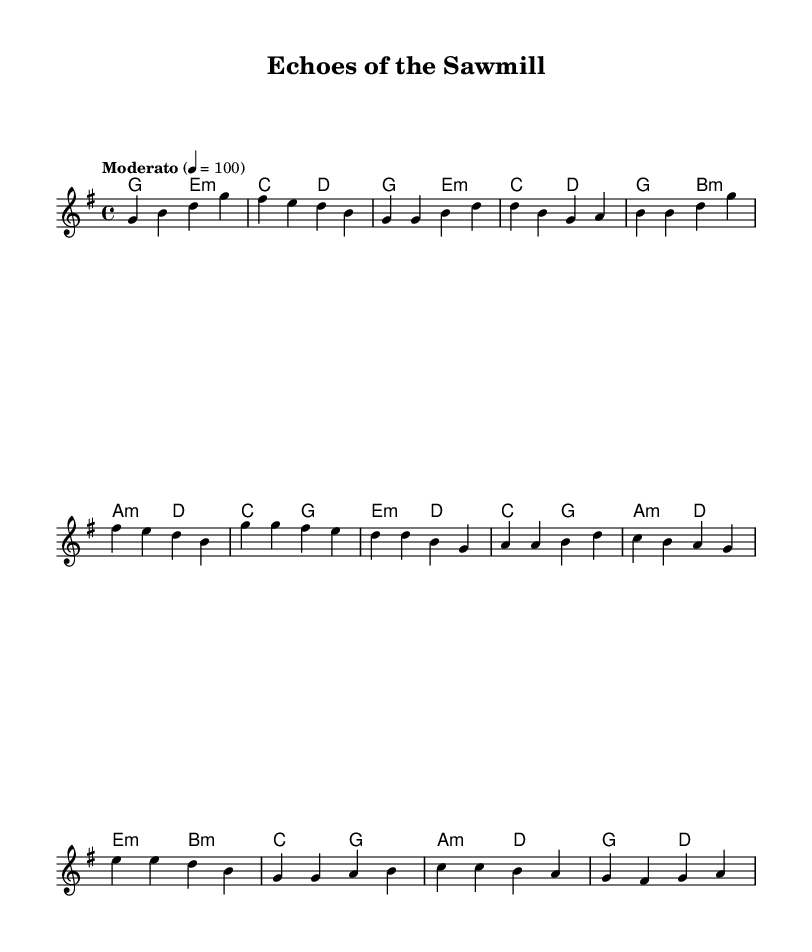What is the key signature of this music? The key signature can be identified by looking at the beginning of the staff, where it shows one sharp. This indicates that the music is in G major.
Answer: G major What is the time signature of this music? The time signature is indicated at the beginning of the staff, where it shows a fraction. In this case, it shows 4/4, which means there are four beats in each measure and the quarter note gets one beat.
Answer: 4/4 What is the tempo marking of this music? The tempo marking is found above the staff, indicating how fast the music should be played. It says "Moderato" and specifies a metronome marking of 100 beats per minute.
Answer: Moderato, 100 How many measures are there in the melody? To find the number of measures, count the divisions separated by vertical lines (bar lines) in the melody part of the sheet music. There are 8 measures in total.
Answer: 8 What is the first chord of the piece? The first chord is identified by looking at the chord symbols written above the staff. The first chord symbol is G major, which appears in the first measure.
Answer: G How many times does the note "g" appear in the melody's first verse? By examining the notes in the melody part, we count how many times the note "g" appears in that section. In the first verse, the note "g" appears 4 times.
Answer: 4 What style fusion is represented in this piece? The style fusion is indicated in the title and suggested by the musical elements. Given the context of lumber mill life along with folk and industrial influences, the style is a nostalgic fusion of Canadian folk and industrial sounds.
Answer: Nostalgic Fusion 